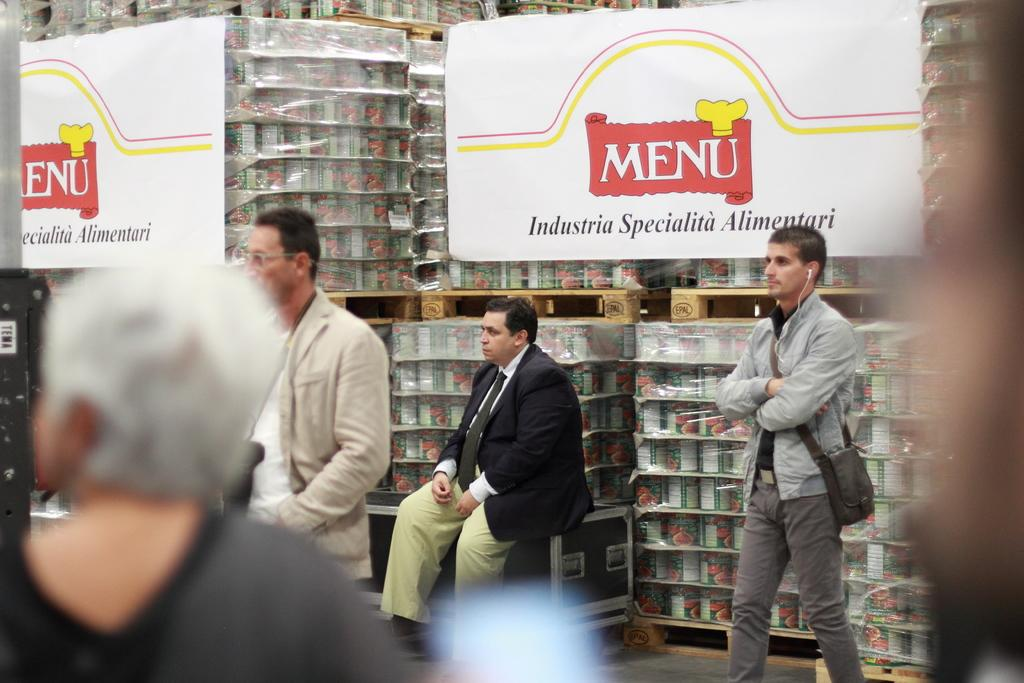What can be seen hanging in the image? There are banners in the image. Who or what is present in the image? There are people in the image. What piece of furniture is visible in the image? There is a table in the image. What type of storage is present in the image? There are shelves in the image, and they are filled with boxes. What type of nail is being used to hang the banners in the image? There is no nail visible in the image; the banners are not described as being hung with a nail. What material is the brass used for in the image? There is no brass mentioned or visible in the image. 